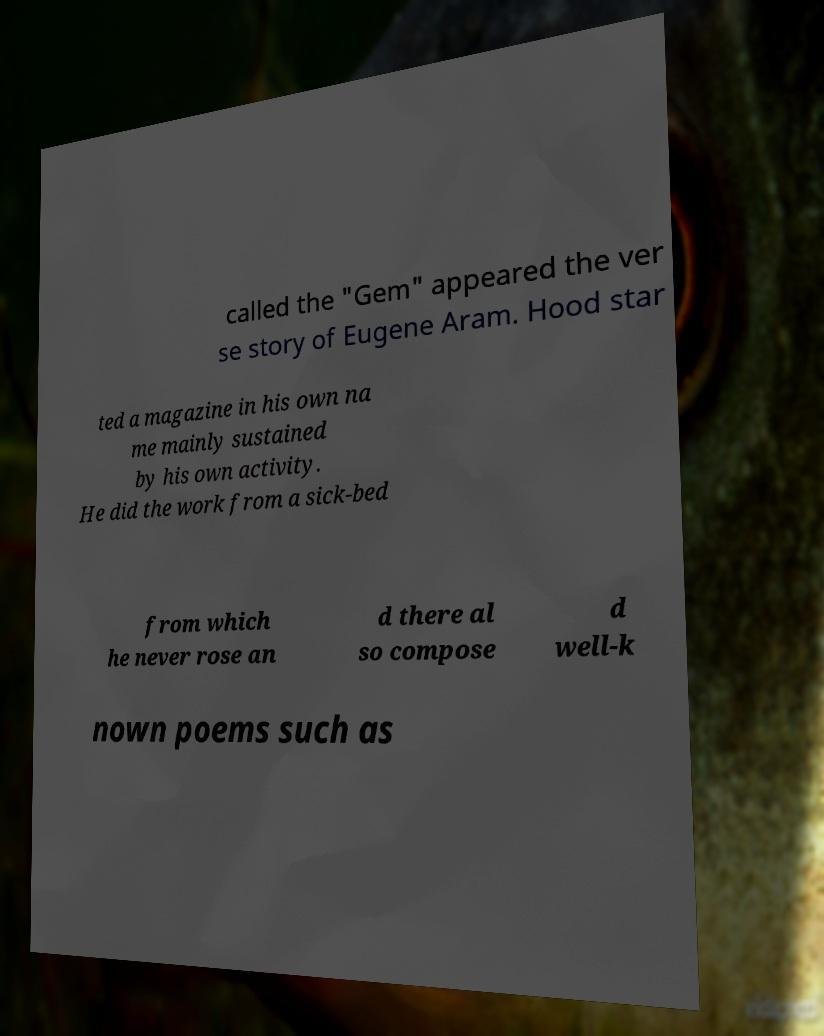I need the written content from this picture converted into text. Can you do that? called the "Gem" appeared the ver se story of Eugene Aram. Hood star ted a magazine in his own na me mainly sustained by his own activity. He did the work from a sick-bed from which he never rose an d there al so compose d well-k nown poems such as 